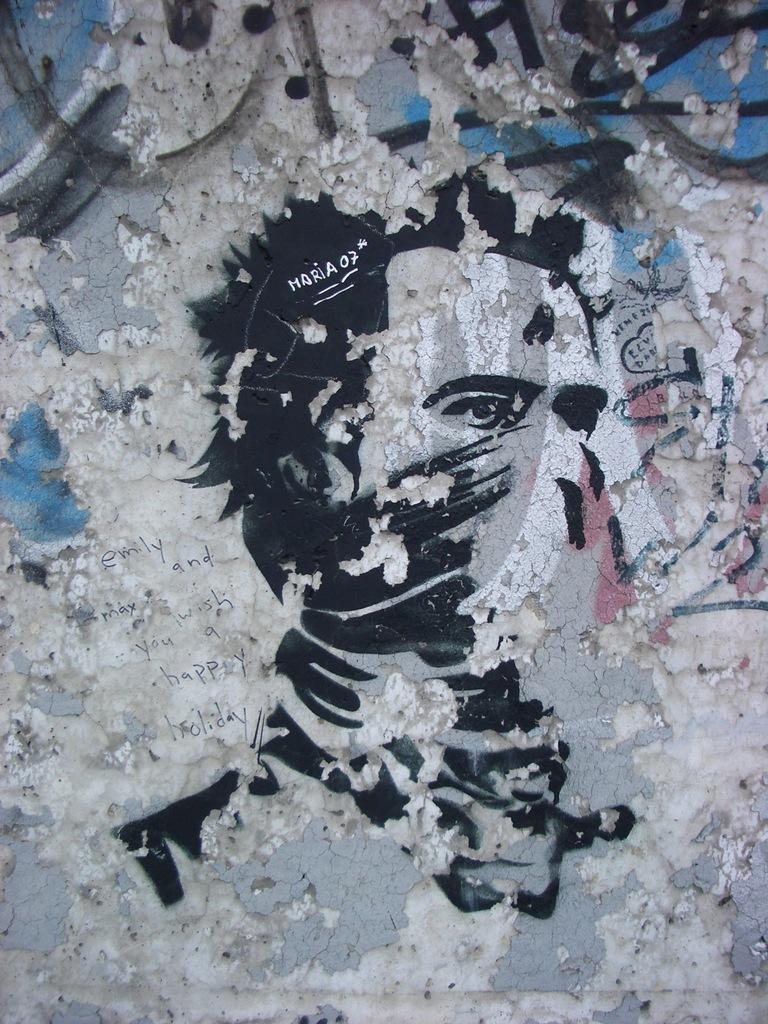Describe this image in one or two sentences. In this image there is a painting and there is some text on the wall. 